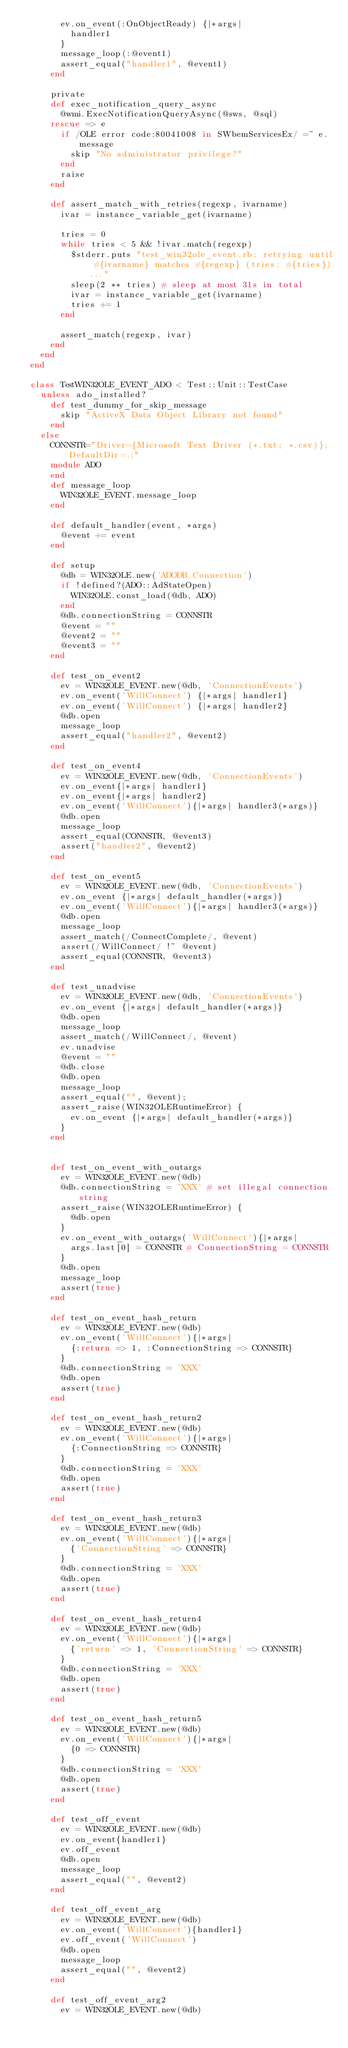Convert code to text. <code><loc_0><loc_0><loc_500><loc_500><_Ruby_>        ev.on_event(:OnObjectReady) {|*args|
          handler1
        }
        message_loop(:@event1)
        assert_equal("handler1", @event1)
      end

      private
      def exec_notification_query_async
        @wmi.ExecNotificationQueryAsync(@sws, @sql)
      rescue => e
        if /OLE error code:80041008 in SWbemServicesEx/ =~ e.message
          skip "No administrator privilege?"
        end
        raise
      end

      def assert_match_with_retries(regexp, ivarname)
        ivar = instance_variable_get(ivarname)

        tries = 0
        while tries < 5 && !ivar.match(regexp)
          $stderr.puts "test_win32ole_event.rb: retrying until #{ivarname} matches #{regexp} (tries: #{tries})..."
          sleep(2 ** tries) # sleep at most 31s in total
          ivar = instance_variable_get(ivarname)
          tries += 1
        end

        assert_match(regexp, ivar)
      end
    end
  end

  class TestWIN32OLE_EVENT_ADO < Test::Unit::TestCase
    unless ado_installed?
      def test_dummy_for_skip_message
        skip "ActiveX Data Object Library not found"
      end
    else
      CONNSTR="Driver={Microsoft Text Driver (*.txt; *.csv)};DefaultDir=.;"
      module ADO
      end
      def message_loop
        WIN32OLE_EVENT.message_loop
      end

      def default_handler(event, *args)
        @event += event
      end

      def setup
        @db = WIN32OLE.new('ADODB.Connection')
        if !defined?(ADO::AdStateOpen)
          WIN32OLE.const_load(@db, ADO)
        end
        @db.connectionString = CONNSTR
        @event = ""
        @event2 = ""
        @event3 = ""
      end

      def test_on_event2
        ev = WIN32OLE_EVENT.new(@db, 'ConnectionEvents')
        ev.on_event('WillConnect') {|*args| handler1}
        ev.on_event('WillConnect') {|*args| handler2}
        @db.open
        message_loop
        assert_equal("handler2", @event2)
      end

      def test_on_event4
        ev = WIN32OLE_EVENT.new(@db, 'ConnectionEvents')
        ev.on_event{|*args| handler1}
        ev.on_event{|*args| handler2}
        ev.on_event('WillConnect'){|*args| handler3(*args)}
        @db.open
        message_loop
        assert_equal(CONNSTR, @event3)
        assert("handler2", @event2)
      end

      def test_on_event5
        ev = WIN32OLE_EVENT.new(@db, 'ConnectionEvents')
        ev.on_event {|*args| default_handler(*args)}
        ev.on_event('WillConnect'){|*args| handler3(*args)}
        @db.open
        message_loop
        assert_match(/ConnectComplete/, @event)
        assert(/WillConnect/ !~ @event)
        assert_equal(CONNSTR, @event3)
      end

      def test_unadvise
        ev = WIN32OLE_EVENT.new(@db, 'ConnectionEvents')
        ev.on_event {|*args| default_handler(*args)}
        @db.open
        message_loop
        assert_match(/WillConnect/, @event)
        ev.unadvise
        @event = ""
        @db.close
        @db.open
        message_loop
        assert_equal("", @event);
        assert_raise(WIN32OLERuntimeError) {
          ev.on_event {|*args| default_handler(*args)}
        }
      end


      def test_on_event_with_outargs
        ev = WIN32OLE_EVENT.new(@db)
        @db.connectionString = 'XXX' # set illegal connection string
        assert_raise(WIN32OLERuntimeError) {
          @db.open
        }
        ev.on_event_with_outargs('WillConnect'){|*args|
          args.last[0] = CONNSTR # ConnectionString = CONNSTR
        }
        @db.open
        message_loop
        assert(true)
      end

      def test_on_event_hash_return
        ev = WIN32OLE_EVENT.new(@db)
        ev.on_event('WillConnect'){|*args|
          {:return => 1, :ConnectionString => CONNSTR}
        }
        @db.connectionString = 'XXX'
        @db.open
        assert(true)
      end

      def test_on_event_hash_return2
        ev = WIN32OLE_EVENT.new(@db)
        ev.on_event('WillConnect'){|*args|
          {:ConnectionString => CONNSTR}
        }
        @db.connectionString = 'XXX'
        @db.open
        assert(true)
      end

      def test_on_event_hash_return3
        ev = WIN32OLE_EVENT.new(@db)
        ev.on_event('WillConnect'){|*args|
          {'ConnectionString' => CONNSTR}
        }
        @db.connectionString = 'XXX'
        @db.open
        assert(true)
      end

      def test_on_event_hash_return4
        ev = WIN32OLE_EVENT.new(@db)
        ev.on_event('WillConnect'){|*args|
          {'return' => 1, 'ConnectionString' => CONNSTR}
        }
        @db.connectionString = 'XXX'
        @db.open
        assert(true)
      end

      def test_on_event_hash_return5
        ev = WIN32OLE_EVENT.new(@db)
        ev.on_event('WillConnect'){|*args|
          {0 => CONNSTR}
        }
        @db.connectionString = 'XXX'
        @db.open
        assert(true)
      end

      def test_off_event
        ev = WIN32OLE_EVENT.new(@db)
        ev.on_event{handler1}
        ev.off_event
        @db.open
        message_loop
        assert_equal("", @event2)
      end

      def test_off_event_arg
        ev = WIN32OLE_EVENT.new(@db)
        ev.on_event('WillConnect'){handler1}
        ev.off_event('WillConnect')
        @db.open
        message_loop
        assert_equal("", @event2)
      end

      def test_off_event_arg2
        ev = WIN32OLE_EVENT.new(@db)</code> 